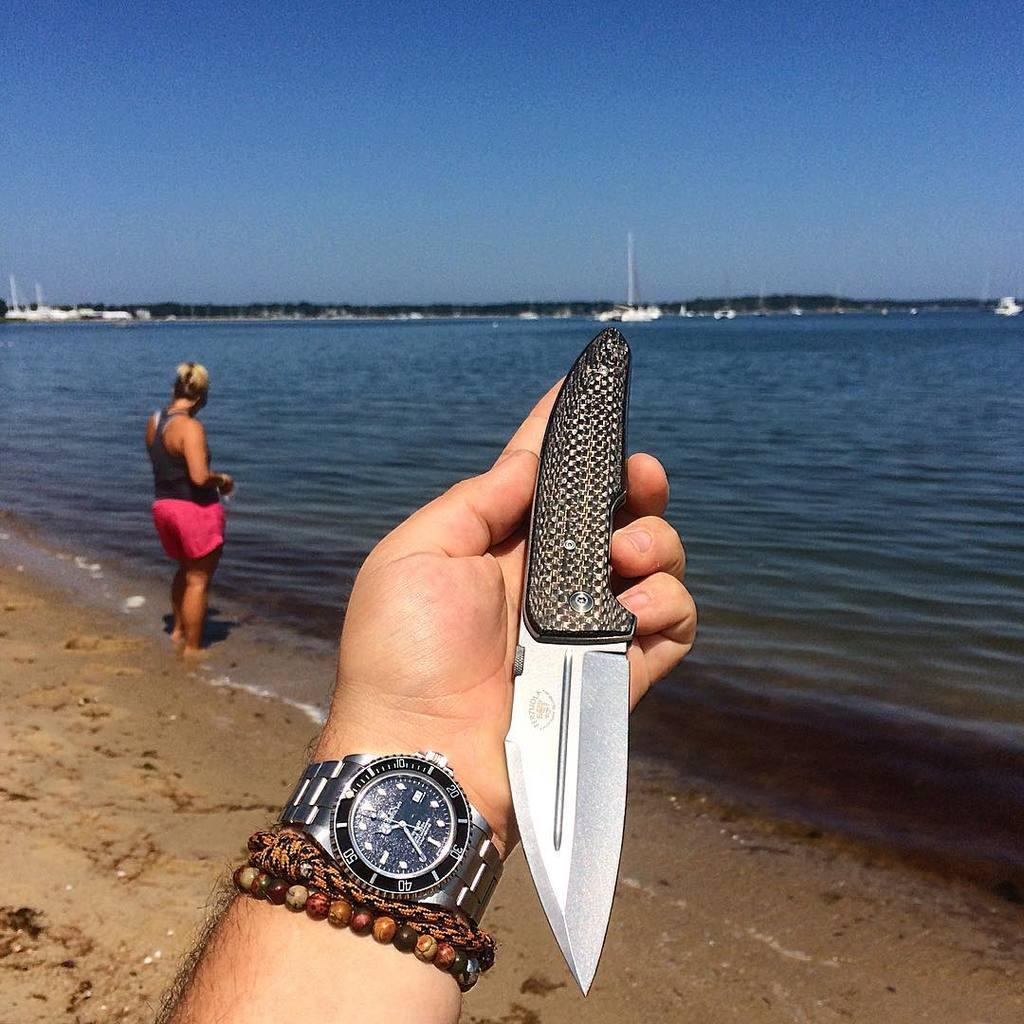<image>
Provide a brief description of the given image. A hand is holding a knife, with a watch on the wrist whose dial has numbers from 10 to 50 around it. 